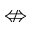Convert formula to latex. <formula><loc_0><loc_0><loc_500><loc_500>\ n L e f t r i g h t a r r o w</formula> 